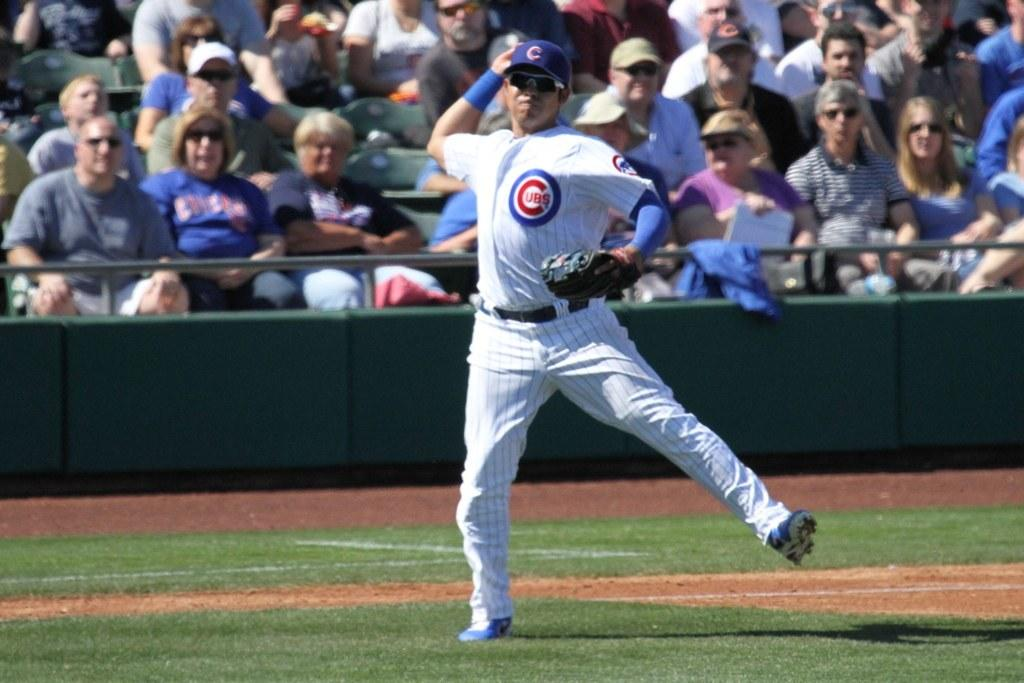Provide a one-sentence caption for the provided image. a man in a cubs uniform playing baseball. 